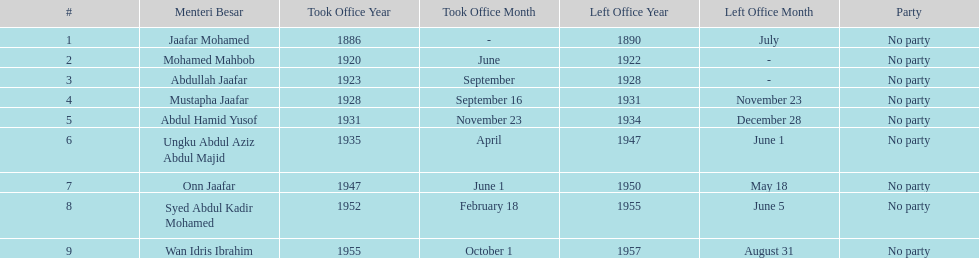Who took office after onn jaafar? Syed Abdul Kadir Mohamed. 